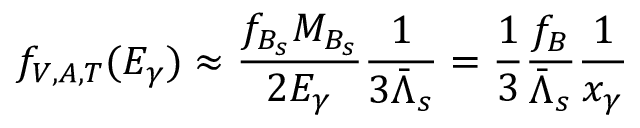Convert formula to latex. <formula><loc_0><loc_0><loc_500><loc_500>f _ { V , A , T } ( E _ { \gamma } ) \approx \frac { f _ { B _ { s } } M _ { B _ { s } } } { 2 E _ { \gamma } } \frac { 1 } { 3 \bar { \Lambda } _ { s } } = \frac { 1 } { 3 } \frac { f _ { B } } { \bar { \Lambda } _ { s } } \frac { 1 } { x _ { \gamma } }</formula> 